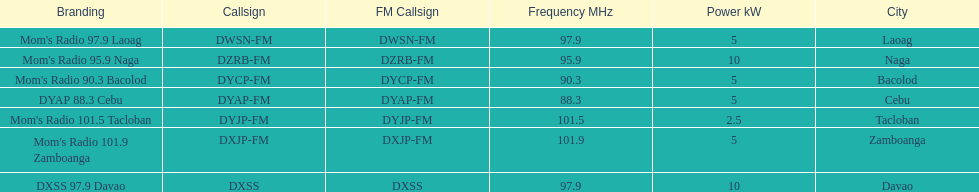What is the radio with the most mhz? Mom's Radio 101.9 Zamboanga. 